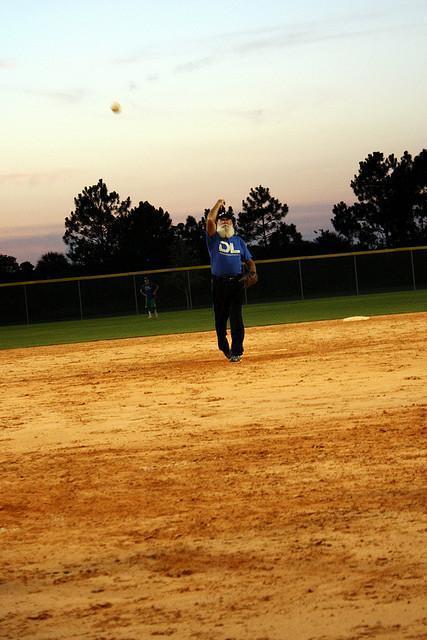How many elephants are in the image?
Give a very brief answer. 0. 